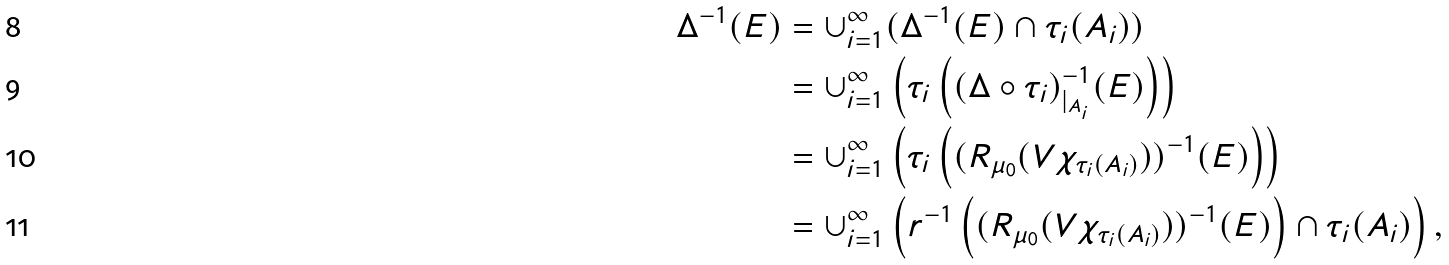<formula> <loc_0><loc_0><loc_500><loc_500>\Delta ^ { - 1 } ( E ) & = \cup _ { i = 1 } ^ { \infty } ( \Delta ^ { - 1 } ( E ) \cap \tau _ { i } ( A _ { i } ) ) \\ & = \cup _ { i = 1 } ^ { \infty } \left ( \tau _ { i } \left ( ( \Delta \circ \tau _ { i } ) _ { | _ { A _ { i } } } ^ { - 1 } ( E ) \right ) \right ) \\ & = \cup _ { i = 1 } ^ { \infty } \left ( \tau _ { i } \left ( ( R _ { \mu _ { 0 } } ( V \chi _ { \tau _ { i } ( A _ { i } ) } ) ) ^ { - 1 } ( E ) \right ) \right ) \\ & = \cup _ { i = 1 } ^ { \infty } \left ( r ^ { - 1 } \left ( ( R _ { \mu _ { 0 } } ( V \chi _ { \tau _ { i } ( A _ { i } ) } ) ) ^ { - 1 } ( E ) \right ) \cap \tau _ { i } ( A _ { i } ) \right ) ,</formula> 